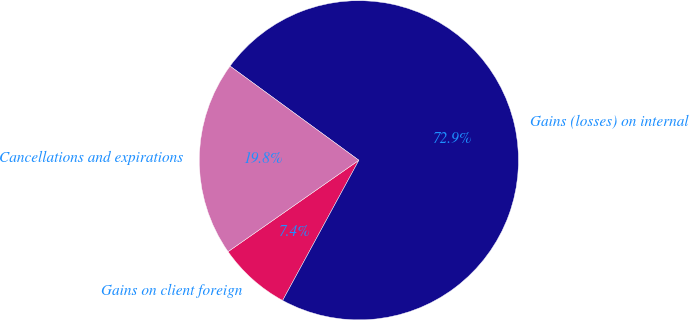Convert chart. <chart><loc_0><loc_0><loc_500><loc_500><pie_chart><fcel>Gains on client foreign<fcel>Gains (losses) on internal<fcel>Cancellations and expirations<nl><fcel>7.37%<fcel>72.88%<fcel>19.75%<nl></chart> 